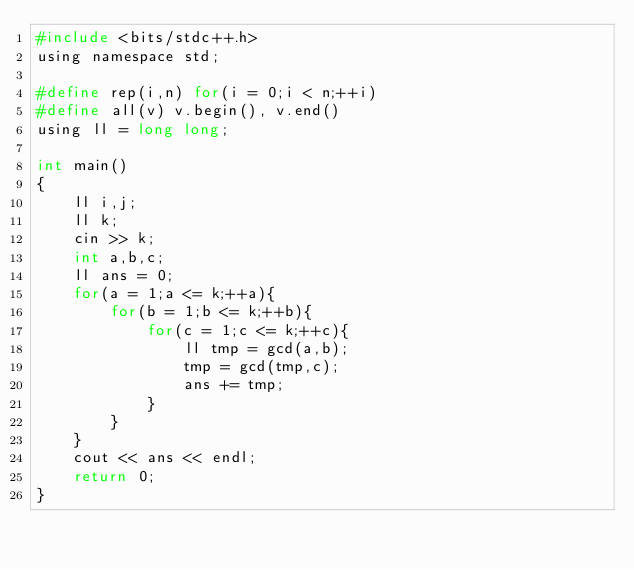<code> <loc_0><loc_0><loc_500><loc_500><_C_>#include <bits/stdc++.h>
using namespace std;

#define rep(i,n) for(i = 0;i < n;++i)
#define all(v) v.begin(), v.end()
using ll = long long;

int main()
{
    ll i,j;
    ll k;
    cin >> k;
    int a,b,c;
    ll ans = 0;
    for(a = 1;a <= k;++a){
        for(b = 1;b <= k;++b){
            for(c = 1;c <= k;++c){
                ll tmp = gcd(a,b);
                tmp = gcd(tmp,c);
                ans += tmp;
            }
        }
    }
    cout << ans << endl;
    return 0;
}</code> 